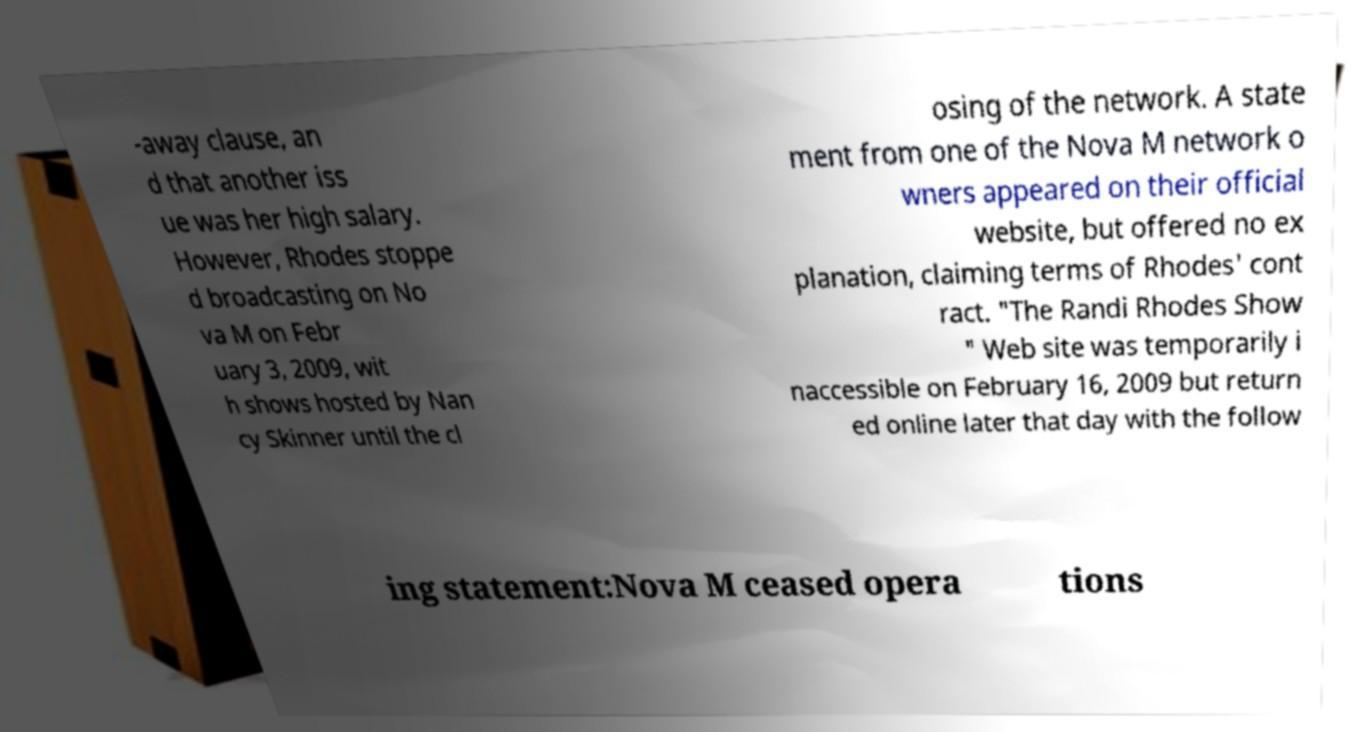What messages or text are displayed in this image? I need them in a readable, typed format. -away clause, an d that another iss ue was her high salary. However, Rhodes stoppe d broadcasting on No va M on Febr uary 3, 2009, wit h shows hosted by Nan cy Skinner until the cl osing of the network. A state ment from one of the Nova M network o wners appeared on their official website, but offered no ex planation, claiming terms of Rhodes' cont ract. "The Randi Rhodes Show " Web site was temporarily i naccessible on February 16, 2009 but return ed online later that day with the follow ing statement:Nova M ceased opera tions 